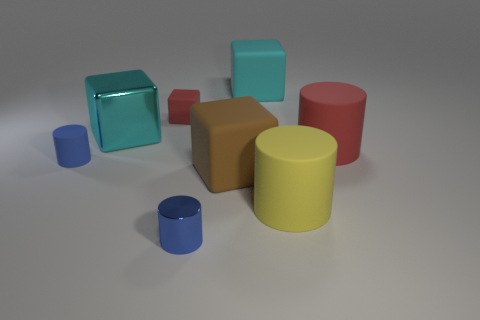Subtract all cyan blocks. How many were subtracted if there are1cyan blocks left? 1 Subtract all tiny metal cylinders. How many cylinders are left? 3 Subtract all red balls. How many cyan cubes are left? 2 Subtract all red blocks. How many blocks are left? 3 Subtract 1 cylinders. How many cylinders are left? 3 Subtract all red cubes. Subtract all green spheres. How many cubes are left? 3 Add 1 tiny rubber cylinders. How many objects exist? 9 Subtract 0 green cubes. How many objects are left? 8 Subtract all cyan rubber objects. Subtract all big things. How many objects are left? 2 Add 5 cyan cubes. How many cyan cubes are left? 7 